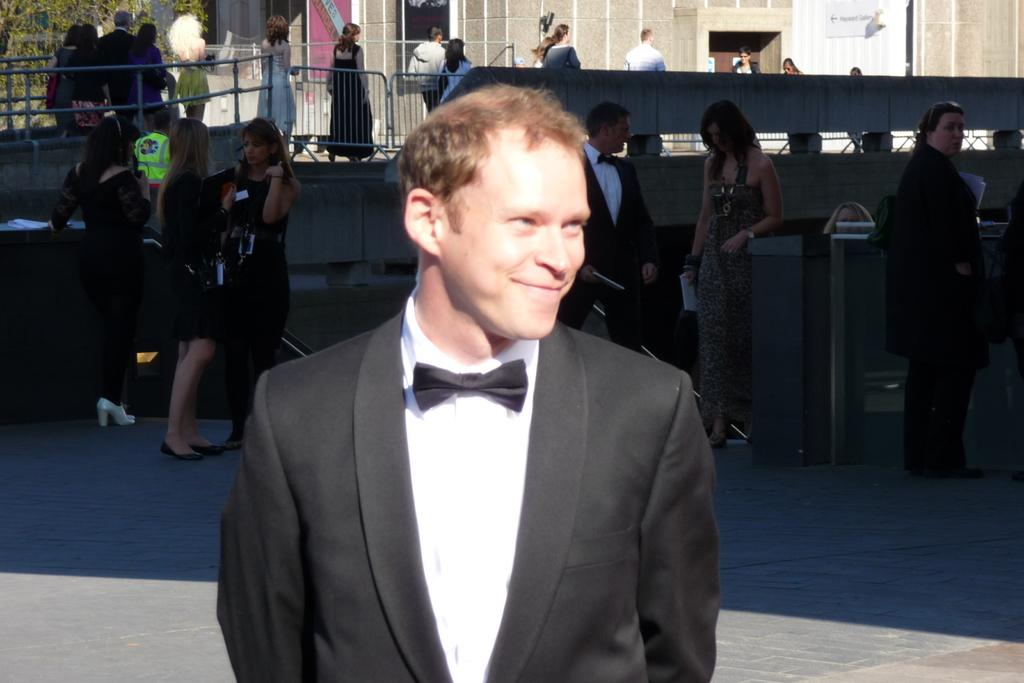What are the people in the image doing on the road? Some people are standing, and others are walking on the road. What can be seen in the background of the image? There are buildings, trees, and grills visible in the background. What question are the women asking in the image? There are no women present in the image, and no one is asking a question. 